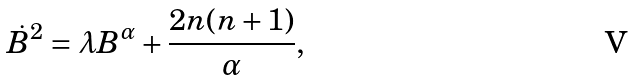<formula> <loc_0><loc_0><loc_500><loc_500>\dot { B } ^ { 2 } = \lambda B ^ { \alpha } + \frac { 2 n ( n + 1 ) } { \alpha } ,</formula> 